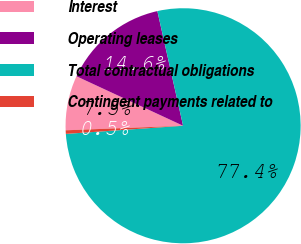<chart> <loc_0><loc_0><loc_500><loc_500><pie_chart><fcel>Interest<fcel>Operating leases<fcel>Total contractual obligations<fcel>Contingent payments related to<nl><fcel>7.53%<fcel>14.57%<fcel>77.41%<fcel>0.49%<nl></chart> 